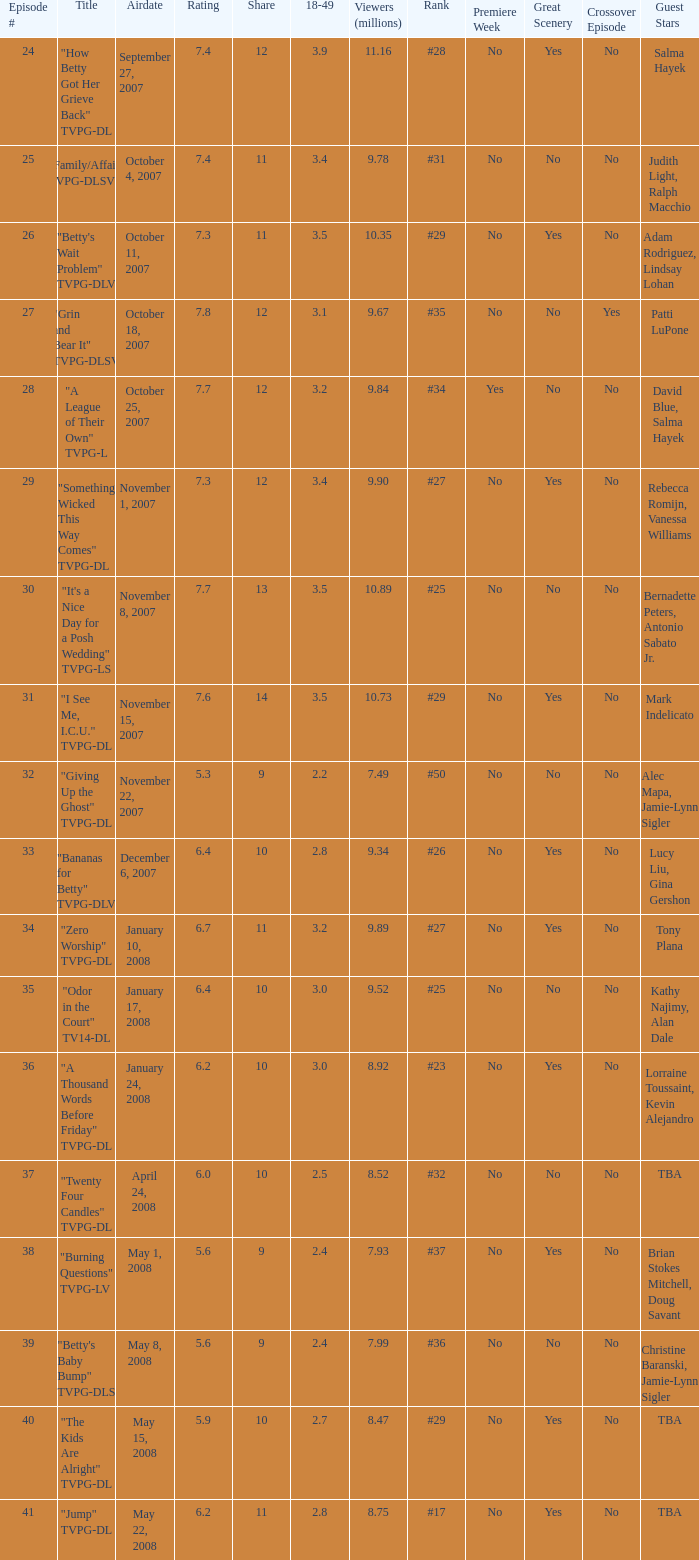What is the Airdate of the episode that ranked #29 and had a share greater than 10? May 15, 2008. 